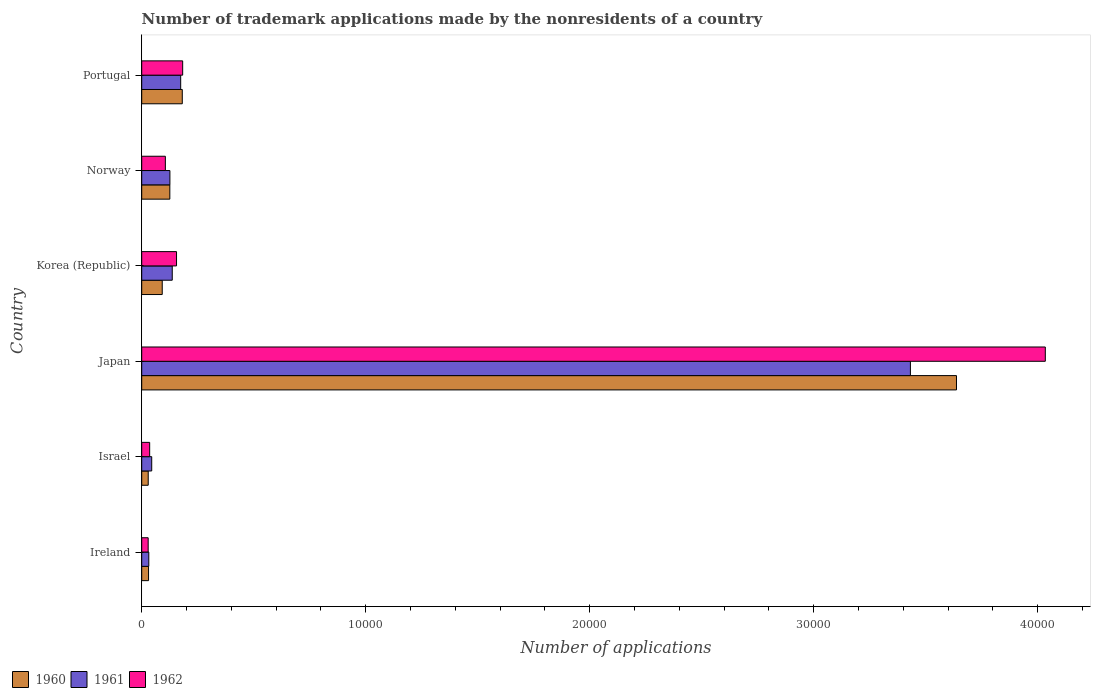How many groups of bars are there?
Give a very brief answer. 6. How many bars are there on the 1st tick from the top?
Make the answer very short. 3. How many bars are there on the 3rd tick from the bottom?
Make the answer very short. 3. What is the number of trademark applications made by the nonresidents in 1962 in Japan?
Your answer should be compact. 4.03e+04. Across all countries, what is the maximum number of trademark applications made by the nonresidents in 1960?
Ensure brevity in your answer.  3.64e+04. Across all countries, what is the minimum number of trademark applications made by the nonresidents in 1961?
Provide a short and direct response. 316. In which country was the number of trademark applications made by the nonresidents in 1961 maximum?
Offer a very short reply. Japan. In which country was the number of trademark applications made by the nonresidents in 1961 minimum?
Ensure brevity in your answer.  Ireland. What is the total number of trademark applications made by the nonresidents in 1960 in the graph?
Provide a short and direct response. 4.10e+04. What is the difference between the number of trademark applications made by the nonresidents in 1960 in Israel and that in Portugal?
Keep it short and to the point. -1521. What is the difference between the number of trademark applications made by the nonresidents in 1960 in Israel and the number of trademark applications made by the nonresidents in 1962 in Ireland?
Offer a terse response. 2. What is the average number of trademark applications made by the nonresidents in 1962 per country?
Give a very brief answer. 7570.5. What is the difference between the number of trademark applications made by the nonresidents in 1961 and number of trademark applications made by the nonresidents in 1960 in Portugal?
Provide a succinct answer. -71. In how many countries, is the number of trademark applications made by the nonresidents in 1961 greater than 12000 ?
Provide a short and direct response. 1. What is the ratio of the number of trademark applications made by the nonresidents in 1962 in Japan to that in Portugal?
Provide a short and direct response. 22.07. Is the number of trademark applications made by the nonresidents in 1961 in Japan less than that in Korea (Republic)?
Your answer should be very brief. No. Is the difference between the number of trademark applications made by the nonresidents in 1961 in Ireland and Korea (Republic) greater than the difference between the number of trademark applications made by the nonresidents in 1960 in Ireland and Korea (Republic)?
Offer a very short reply. No. What is the difference between the highest and the second highest number of trademark applications made by the nonresidents in 1961?
Keep it short and to the point. 3.26e+04. What is the difference between the highest and the lowest number of trademark applications made by the nonresidents in 1962?
Your response must be concise. 4.01e+04. In how many countries, is the number of trademark applications made by the nonresidents in 1960 greater than the average number of trademark applications made by the nonresidents in 1960 taken over all countries?
Provide a short and direct response. 1. What does the 1st bar from the top in Norway represents?
Provide a succinct answer. 1962. What does the 2nd bar from the bottom in Japan represents?
Provide a short and direct response. 1961. How many bars are there?
Your response must be concise. 18. Are all the bars in the graph horizontal?
Provide a short and direct response. Yes. How many countries are there in the graph?
Provide a succinct answer. 6. How many legend labels are there?
Your response must be concise. 3. What is the title of the graph?
Your response must be concise. Number of trademark applications made by the nonresidents of a country. Does "1986" appear as one of the legend labels in the graph?
Your answer should be compact. No. What is the label or title of the X-axis?
Offer a very short reply. Number of applications. What is the label or title of the Y-axis?
Give a very brief answer. Country. What is the Number of applications in 1960 in Ireland?
Keep it short and to the point. 305. What is the Number of applications of 1961 in Ireland?
Offer a very short reply. 316. What is the Number of applications in 1962 in Ireland?
Give a very brief answer. 288. What is the Number of applications of 1960 in Israel?
Offer a very short reply. 290. What is the Number of applications of 1961 in Israel?
Provide a short and direct response. 446. What is the Number of applications of 1962 in Israel?
Your response must be concise. 355. What is the Number of applications in 1960 in Japan?
Your answer should be very brief. 3.64e+04. What is the Number of applications of 1961 in Japan?
Your answer should be compact. 3.43e+04. What is the Number of applications of 1962 in Japan?
Provide a succinct answer. 4.03e+04. What is the Number of applications in 1960 in Korea (Republic)?
Make the answer very short. 916. What is the Number of applications in 1961 in Korea (Republic)?
Offer a very short reply. 1363. What is the Number of applications in 1962 in Korea (Republic)?
Your response must be concise. 1554. What is the Number of applications in 1960 in Norway?
Your response must be concise. 1255. What is the Number of applications of 1961 in Norway?
Provide a succinct answer. 1258. What is the Number of applications in 1962 in Norway?
Give a very brief answer. 1055. What is the Number of applications in 1960 in Portugal?
Ensure brevity in your answer.  1811. What is the Number of applications of 1961 in Portugal?
Offer a terse response. 1740. What is the Number of applications in 1962 in Portugal?
Your answer should be very brief. 1828. Across all countries, what is the maximum Number of applications of 1960?
Provide a short and direct response. 3.64e+04. Across all countries, what is the maximum Number of applications of 1961?
Your response must be concise. 3.43e+04. Across all countries, what is the maximum Number of applications in 1962?
Offer a terse response. 4.03e+04. Across all countries, what is the minimum Number of applications in 1960?
Make the answer very short. 290. Across all countries, what is the minimum Number of applications of 1961?
Keep it short and to the point. 316. Across all countries, what is the minimum Number of applications in 1962?
Make the answer very short. 288. What is the total Number of applications of 1960 in the graph?
Your response must be concise. 4.10e+04. What is the total Number of applications of 1961 in the graph?
Your response must be concise. 3.94e+04. What is the total Number of applications of 1962 in the graph?
Your response must be concise. 4.54e+04. What is the difference between the Number of applications of 1960 in Ireland and that in Israel?
Give a very brief answer. 15. What is the difference between the Number of applications of 1961 in Ireland and that in Israel?
Your answer should be very brief. -130. What is the difference between the Number of applications of 1962 in Ireland and that in Israel?
Your answer should be compact. -67. What is the difference between the Number of applications in 1960 in Ireland and that in Japan?
Offer a very short reply. -3.61e+04. What is the difference between the Number of applications in 1961 in Ireland and that in Japan?
Your response must be concise. -3.40e+04. What is the difference between the Number of applications of 1962 in Ireland and that in Japan?
Offer a terse response. -4.01e+04. What is the difference between the Number of applications of 1960 in Ireland and that in Korea (Republic)?
Ensure brevity in your answer.  -611. What is the difference between the Number of applications of 1961 in Ireland and that in Korea (Republic)?
Offer a terse response. -1047. What is the difference between the Number of applications of 1962 in Ireland and that in Korea (Republic)?
Give a very brief answer. -1266. What is the difference between the Number of applications in 1960 in Ireland and that in Norway?
Offer a very short reply. -950. What is the difference between the Number of applications in 1961 in Ireland and that in Norway?
Your response must be concise. -942. What is the difference between the Number of applications of 1962 in Ireland and that in Norway?
Make the answer very short. -767. What is the difference between the Number of applications in 1960 in Ireland and that in Portugal?
Provide a short and direct response. -1506. What is the difference between the Number of applications of 1961 in Ireland and that in Portugal?
Make the answer very short. -1424. What is the difference between the Number of applications in 1962 in Ireland and that in Portugal?
Your answer should be very brief. -1540. What is the difference between the Number of applications of 1960 in Israel and that in Japan?
Your response must be concise. -3.61e+04. What is the difference between the Number of applications of 1961 in Israel and that in Japan?
Your response must be concise. -3.39e+04. What is the difference between the Number of applications in 1962 in Israel and that in Japan?
Make the answer very short. -4.00e+04. What is the difference between the Number of applications of 1960 in Israel and that in Korea (Republic)?
Your answer should be compact. -626. What is the difference between the Number of applications in 1961 in Israel and that in Korea (Republic)?
Offer a terse response. -917. What is the difference between the Number of applications of 1962 in Israel and that in Korea (Republic)?
Offer a very short reply. -1199. What is the difference between the Number of applications of 1960 in Israel and that in Norway?
Give a very brief answer. -965. What is the difference between the Number of applications in 1961 in Israel and that in Norway?
Provide a short and direct response. -812. What is the difference between the Number of applications of 1962 in Israel and that in Norway?
Offer a very short reply. -700. What is the difference between the Number of applications of 1960 in Israel and that in Portugal?
Your response must be concise. -1521. What is the difference between the Number of applications in 1961 in Israel and that in Portugal?
Make the answer very short. -1294. What is the difference between the Number of applications in 1962 in Israel and that in Portugal?
Make the answer very short. -1473. What is the difference between the Number of applications in 1960 in Japan and that in Korea (Republic)?
Provide a short and direct response. 3.55e+04. What is the difference between the Number of applications in 1961 in Japan and that in Korea (Republic)?
Offer a very short reply. 3.30e+04. What is the difference between the Number of applications in 1962 in Japan and that in Korea (Republic)?
Your answer should be compact. 3.88e+04. What is the difference between the Number of applications in 1960 in Japan and that in Norway?
Offer a terse response. 3.51e+04. What is the difference between the Number of applications in 1961 in Japan and that in Norway?
Offer a terse response. 3.31e+04. What is the difference between the Number of applications of 1962 in Japan and that in Norway?
Make the answer very short. 3.93e+04. What is the difference between the Number of applications in 1960 in Japan and that in Portugal?
Your answer should be very brief. 3.46e+04. What is the difference between the Number of applications in 1961 in Japan and that in Portugal?
Provide a short and direct response. 3.26e+04. What is the difference between the Number of applications in 1962 in Japan and that in Portugal?
Provide a succinct answer. 3.85e+04. What is the difference between the Number of applications in 1960 in Korea (Republic) and that in Norway?
Provide a short and direct response. -339. What is the difference between the Number of applications in 1961 in Korea (Republic) and that in Norway?
Provide a short and direct response. 105. What is the difference between the Number of applications in 1962 in Korea (Republic) and that in Norway?
Your answer should be compact. 499. What is the difference between the Number of applications of 1960 in Korea (Republic) and that in Portugal?
Your answer should be very brief. -895. What is the difference between the Number of applications of 1961 in Korea (Republic) and that in Portugal?
Offer a very short reply. -377. What is the difference between the Number of applications in 1962 in Korea (Republic) and that in Portugal?
Give a very brief answer. -274. What is the difference between the Number of applications in 1960 in Norway and that in Portugal?
Give a very brief answer. -556. What is the difference between the Number of applications in 1961 in Norway and that in Portugal?
Give a very brief answer. -482. What is the difference between the Number of applications of 1962 in Norway and that in Portugal?
Keep it short and to the point. -773. What is the difference between the Number of applications of 1960 in Ireland and the Number of applications of 1961 in Israel?
Your answer should be very brief. -141. What is the difference between the Number of applications in 1961 in Ireland and the Number of applications in 1962 in Israel?
Your answer should be compact. -39. What is the difference between the Number of applications in 1960 in Ireland and the Number of applications in 1961 in Japan?
Provide a succinct answer. -3.40e+04. What is the difference between the Number of applications of 1960 in Ireland and the Number of applications of 1962 in Japan?
Your response must be concise. -4.00e+04. What is the difference between the Number of applications in 1961 in Ireland and the Number of applications in 1962 in Japan?
Offer a very short reply. -4.00e+04. What is the difference between the Number of applications in 1960 in Ireland and the Number of applications in 1961 in Korea (Republic)?
Give a very brief answer. -1058. What is the difference between the Number of applications in 1960 in Ireland and the Number of applications in 1962 in Korea (Republic)?
Ensure brevity in your answer.  -1249. What is the difference between the Number of applications in 1961 in Ireland and the Number of applications in 1962 in Korea (Republic)?
Your response must be concise. -1238. What is the difference between the Number of applications in 1960 in Ireland and the Number of applications in 1961 in Norway?
Keep it short and to the point. -953. What is the difference between the Number of applications in 1960 in Ireland and the Number of applications in 1962 in Norway?
Your answer should be compact. -750. What is the difference between the Number of applications in 1961 in Ireland and the Number of applications in 1962 in Norway?
Ensure brevity in your answer.  -739. What is the difference between the Number of applications of 1960 in Ireland and the Number of applications of 1961 in Portugal?
Ensure brevity in your answer.  -1435. What is the difference between the Number of applications of 1960 in Ireland and the Number of applications of 1962 in Portugal?
Offer a terse response. -1523. What is the difference between the Number of applications in 1961 in Ireland and the Number of applications in 1962 in Portugal?
Offer a very short reply. -1512. What is the difference between the Number of applications in 1960 in Israel and the Number of applications in 1961 in Japan?
Offer a terse response. -3.40e+04. What is the difference between the Number of applications in 1960 in Israel and the Number of applications in 1962 in Japan?
Your answer should be compact. -4.01e+04. What is the difference between the Number of applications of 1961 in Israel and the Number of applications of 1962 in Japan?
Offer a terse response. -3.99e+04. What is the difference between the Number of applications of 1960 in Israel and the Number of applications of 1961 in Korea (Republic)?
Provide a succinct answer. -1073. What is the difference between the Number of applications of 1960 in Israel and the Number of applications of 1962 in Korea (Republic)?
Provide a short and direct response. -1264. What is the difference between the Number of applications in 1961 in Israel and the Number of applications in 1962 in Korea (Republic)?
Make the answer very short. -1108. What is the difference between the Number of applications in 1960 in Israel and the Number of applications in 1961 in Norway?
Your answer should be compact. -968. What is the difference between the Number of applications of 1960 in Israel and the Number of applications of 1962 in Norway?
Your answer should be very brief. -765. What is the difference between the Number of applications in 1961 in Israel and the Number of applications in 1962 in Norway?
Give a very brief answer. -609. What is the difference between the Number of applications in 1960 in Israel and the Number of applications in 1961 in Portugal?
Your answer should be very brief. -1450. What is the difference between the Number of applications of 1960 in Israel and the Number of applications of 1962 in Portugal?
Keep it short and to the point. -1538. What is the difference between the Number of applications of 1961 in Israel and the Number of applications of 1962 in Portugal?
Provide a succinct answer. -1382. What is the difference between the Number of applications of 1960 in Japan and the Number of applications of 1961 in Korea (Republic)?
Keep it short and to the point. 3.50e+04. What is the difference between the Number of applications in 1960 in Japan and the Number of applications in 1962 in Korea (Republic)?
Your answer should be compact. 3.48e+04. What is the difference between the Number of applications in 1961 in Japan and the Number of applications in 1962 in Korea (Republic)?
Your response must be concise. 3.28e+04. What is the difference between the Number of applications in 1960 in Japan and the Number of applications in 1961 in Norway?
Provide a short and direct response. 3.51e+04. What is the difference between the Number of applications of 1960 in Japan and the Number of applications of 1962 in Norway?
Ensure brevity in your answer.  3.53e+04. What is the difference between the Number of applications of 1961 in Japan and the Number of applications of 1962 in Norway?
Your answer should be very brief. 3.33e+04. What is the difference between the Number of applications of 1960 in Japan and the Number of applications of 1961 in Portugal?
Your answer should be very brief. 3.46e+04. What is the difference between the Number of applications of 1960 in Japan and the Number of applications of 1962 in Portugal?
Provide a succinct answer. 3.45e+04. What is the difference between the Number of applications of 1961 in Japan and the Number of applications of 1962 in Portugal?
Ensure brevity in your answer.  3.25e+04. What is the difference between the Number of applications of 1960 in Korea (Republic) and the Number of applications of 1961 in Norway?
Ensure brevity in your answer.  -342. What is the difference between the Number of applications of 1960 in Korea (Republic) and the Number of applications of 1962 in Norway?
Your answer should be very brief. -139. What is the difference between the Number of applications in 1961 in Korea (Republic) and the Number of applications in 1962 in Norway?
Keep it short and to the point. 308. What is the difference between the Number of applications in 1960 in Korea (Republic) and the Number of applications in 1961 in Portugal?
Your response must be concise. -824. What is the difference between the Number of applications of 1960 in Korea (Republic) and the Number of applications of 1962 in Portugal?
Your answer should be very brief. -912. What is the difference between the Number of applications of 1961 in Korea (Republic) and the Number of applications of 1962 in Portugal?
Offer a very short reply. -465. What is the difference between the Number of applications of 1960 in Norway and the Number of applications of 1961 in Portugal?
Keep it short and to the point. -485. What is the difference between the Number of applications of 1960 in Norway and the Number of applications of 1962 in Portugal?
Your answer should be very brief. -573. What is the difference between the Number of applications in 1961 in Norway and the Number of applications in 1962 in Portugal?
Provide a succinct answer. -570. What is the average Number of applications in 1960 per country?
Make the answer very short. 6825.67. What is the average Number of applications in 1961 per country?
Your answer should be compact. 6573.83. What is the average Number of applications of 1962 per country?
Offer a very short reply. 7570.5. What is the difference between the Number of applications in 1960 and Number of applications in 1962 in Ireland?
Give a very brief answer. 17. What is the difference between the Number of applications of 1961 and Number of applications of 1962 in Ireland?
Provide a succinct answer. 28. What is the difference between the Number of applications of 1960 and Number of applications of 1961 in Israel?
Provide a short and direct response. -156. What is the difference between the Number of applications in 1960 and Number of applications in 1962 in Israel?
Make the answer very short. -65. What is the difference between the Number of applications in 1961 and Number of applications in 1962 in Israel?
Ensure brevity in your answer.  91. What is the difference between the Number of applications of 1960 and Number of applications of 1961 in Japan?
Keep it short and to the point. 2057. What is the difference between the Number of applications of 1960 and Number of applications of 1962 in Japan?
Your response must be concise. -3966. What is the difference between the Number of applications in 1961 and Number of applications in 1962 in Japan?
Provide a short and direct response. -6023. What is the difference between the Number of applications of 1960 and Number of applications of 1961 in Korea (Republic)?
Offer a terse response. -447. What is the difference between the Number of applications in 1960 and Number of applications in 1962 in Korea (Republic)?
Give a very brief answer. -638. What is the difference between the Number of applications of 1961 and Number of applications of 1962 in Korea (Republic)?
Provide a short and direct response. -191. What is the difference between the Number of applications of 1961 and Number of applications of 1962 in Norway?
Make the answer very short. 203. What is the difference between the Number of applications of 1961 and Number of applications of 1962 in Portugal?
Your response must be concise. -88. What is the ratio of the Number of applications in 1960 in Ireland to that in Israel?
Give a very brief answer. 1.05. What is the ratio of the Number of applications in 1961 in Ireland to that in Israel?
Your response must be concise. 0.71. What is the ratio of the Number of applications of 1962 in Ireland to that in Israel?
Offer a very short reply. 0.81. What is the ratio of the Number of applications of 1960 in Ireland to that in Japan?
Your answer should be very brief. 0.01. What is the ratio of the Number of applications of 1961 in Ireland to that in Japan?
Give a very brief answer. 0.01. What is the ratio of the Number of applications in 1962 in Ireland to that in Japan?
Offer a terse response. 0.01. What is the ratio of the Number of applications in 1960 in Ireland to that in Korea (Republic)?
Give a very brief answer. 0.33. What is the ratio of the Number of applications of 1961 in Ireland to that in Korea (Republic)?
Your response must be concise. 0.23. What is the ratio of the Number of applications in 1962 in Ireland to that in Korea (Republic)?
Give a very brief answer. 0.19. What is the ratio of the Number of applications of 1960 in Ireland to that in Norway?
Your answer should be very brief. 0.24. What is the ratio of the Number of applications in 1961 in Ireland to that in Norway?
Give a very brief answer. 0.25. What is the ratio of the Number of applications of 1962 in Ireland to that in Norway?
Offer a very short reply. 0.27. What is the ratio of the Number of applications of 1960 in Ireland to that in Portugal?
Ensure brevity in your answer.  0.17. What is the ratio of the Number of applications in 1961 in Ireland to that in Portugal?
Ensure brevity in your answer.  0.18. What is the ratio of the Number of applications in 1962 in Ireland to that in Portugal?
Make the answer very short. 0.16. What is the ratio of the Number of applications of 1960 in Israel to that in Japan?
Your answer should be compact. 0.01. What is the ratio of the Number of applications in 1961 in Israel to that in Japan?
Your answer should be compact. 0.01. What is the ratio of the Number of applications of 1962 in Israel to that in Japan?
Your answer should be very brief. 0.01. What is the ratio of the Number of applications of 1960 in Israel to that in Korea (Republic)?
Give a very brief answer. 0.32. What is the ratio of the Number of applications of 1961 in Israel to that in Korea (Republic)?
Provide a short and direct response. 0.33. What is the ratio of the Number of applications in 1962 in Israel to that in Korea (Republic)?
Offer a terse response. 0.23. What is the ratio of the Number of applications of 1960 in Israel to that in Norway?
Your answer should be very brief. 0.23. What is the ratio of the Number of applications of 1961 in Israel to that in Norway?
Give a very brief answer. 0.35. What is the ratio of the Number of applications of 1962 in Israel to that in Norway?
Your answer should be very brief. 0.34. What is the ratio of the Number of applications in 1960 in Israel to that in Portugal?
Offer a terse response. 0.16. What is the ratio of the Number of applications in 1961 in Israel to that in Portugal?
Provide a short and direct response. 0.26. What is the ratio of the Number of applications of 1962 in Israel to that in Portugal?
Provide a succinct answer. 0.19. What is the ratio of the Number of applications in 1960 in Japan to that in Korea (Republic)?
Keep it short and to the point. 39.71. What is the ratio of the Number of applications in 1961 in Japan to that in Korea (Republic)?
Your response must be concise. 25.18. What is the ratio of the Number of applications of 1962 in Japan to that in Korea (Republic)?
Your answer should be very brief. 25.96. What is the ratio of the Number of applications of 1960 in Japan to that in Norway?
Offer a terse response. 28.99. What is the ratio of the Number of applications in 1961 in Japan to that in Norway?
Your answer should be compact. 27.28. What is the ratio of the Number of applications of 1962 in Japan to that in Norway?
Your answer should be very brief. 38.24. What is the ratio of the Number of applications in 1960 in Japan to that in Portugal?
Your response must be concise. 20.09. What is the ratio of the Number of applications in 1961 in Japan to that in Portugal?
Your answer should be compact. 19.72. What is the ratio of the Number of applications of 1962 in Japan to that in Portugal?
Provide a short and direct response. 22.07. What is the ratio of the Number of applications of 1960 in Korea (Republic) to that in Norway?
Offer a very short reply. 0.73. What is the ratio of the Number of applications of 1961 in Korea (Republic) to that in Norway?
Provide a short and direct response. 1.08. What is the ratio of the Number of applications in 1962 in Korea (Republic) to that in Norway?
Offer a terse response. 1.47. What is the ratio of the Number of applications in 1960 in Korea (Republic) to that in Portugal?
Ensure brevity in your answer.  0.51. What is the ratio of the Number of applications in 1961 in Korea (Republic) to that in Portugal?
Your response must be concise. 0.78. What is the ratio of the Number of applications of 1962 in Korea (Republic) to that in Portugal?
Offer a very short reply. 0.85. What is the ratio of the Number of applications in 1960 in Norway to that in Portugal?
Your answer should be very brief. 0.69. What is the ratio of the Number of applications of 1961 in Norway to that in Portugal?
Provide a short and direct response. 0.72. What is the ratio of the Number of applications of 1962 in Norway to that in Portugal?
Your answer should be compact. 0.58. What is the difference between the highest and the second highest Number of applications in 1960?
Your response must be concise. 3.46e+04. What is the difference between the highest and the second highest Number of applications of 1961?
Offer a very short reply. 3.26e+04. What is the difference between the highest and the second highest Number of applications in 1962?
Give a very brief answer. 3.85e+04. What is the difference between the highest and the lowest Number of applications in 1960?
Make the answer very short. 3.61e+04. What is the difference between the highest and the lowest Number of applications in 1961?
Your answer should be compact. 3.40e+04. What is the difference between the highest and the lowest Number of applications of 1962?
Offer a very short reply. 4.01e+04. 